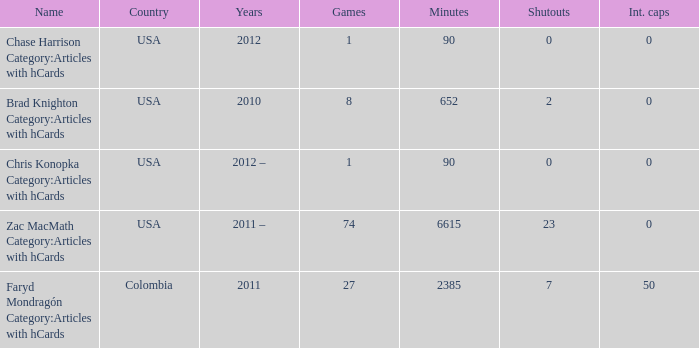When  chris konopka category:articles with hcards is the name what is the year? 2012 –. 